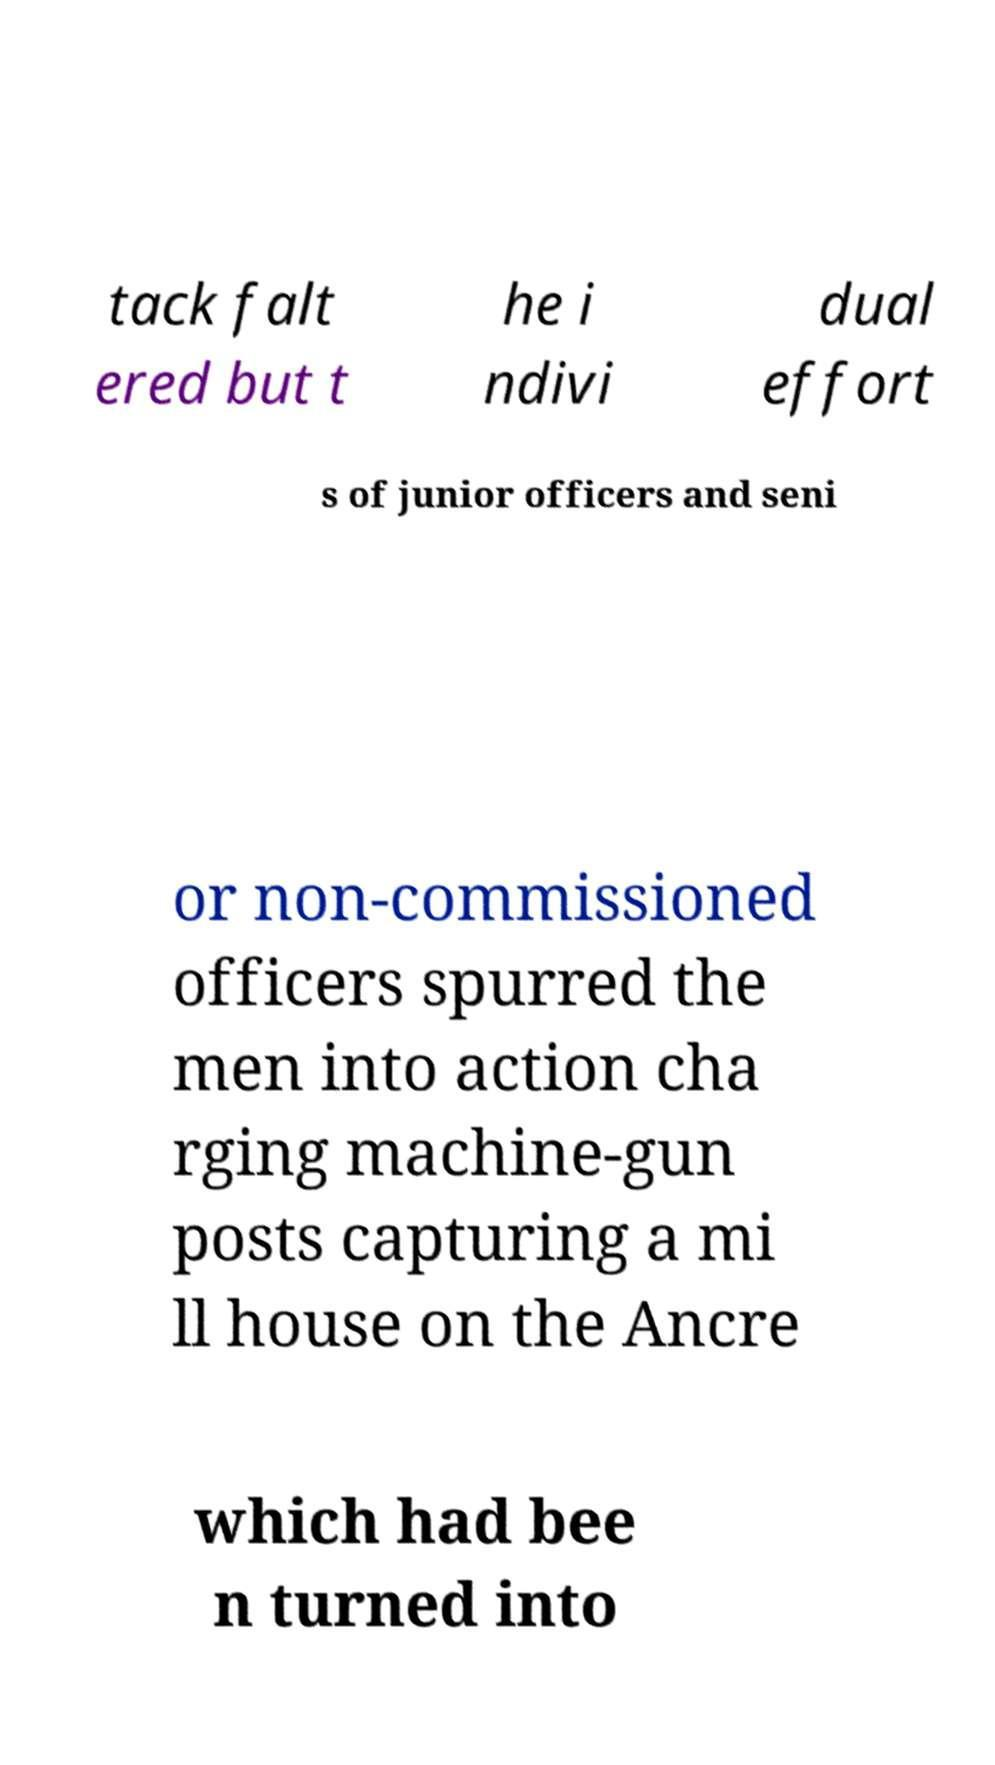Could you assist in decoding the text presented in this image and type it out clearly? tack falt ered but t he i ndivi dual effort s of junior officers and seni or non-commissioned officers spurred the men into action cha rging machine-gun posts capturing a mi ll house on the Ancre which had bee n turned into 